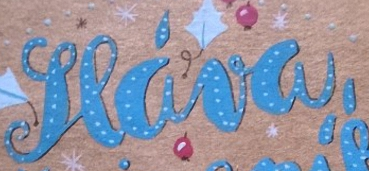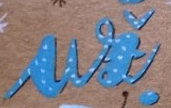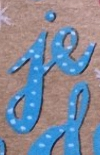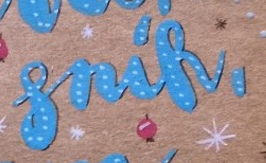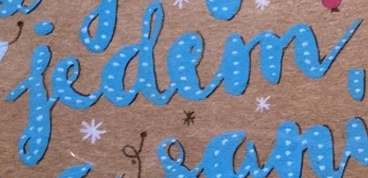Read the text content from these images in order, separated by a semicolon. seáva,; ui; je; snik,; iedem 